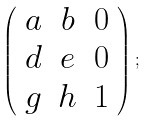<formula> <loc_0><loc_0><loc_500><loc_500>\left ( \begin{array} { c c c } a & b & 0 \\ d & e & 0 \\ g & h & 1 \end{array} \right ) ;</formula> 